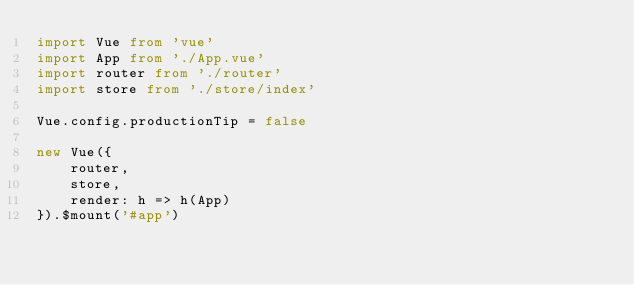Convert code to text. <code><loc_0><loc_0><loc_500><loc_500><_TypeScript_>import Vue from 'vue'
import App from './App.vue'
import router from './router'
import store from './store/index'

Vue.config.productionTip = false

new Vue({
    router,
    store,
    render: h => h(App)
}).$mount('#app')
</code> 